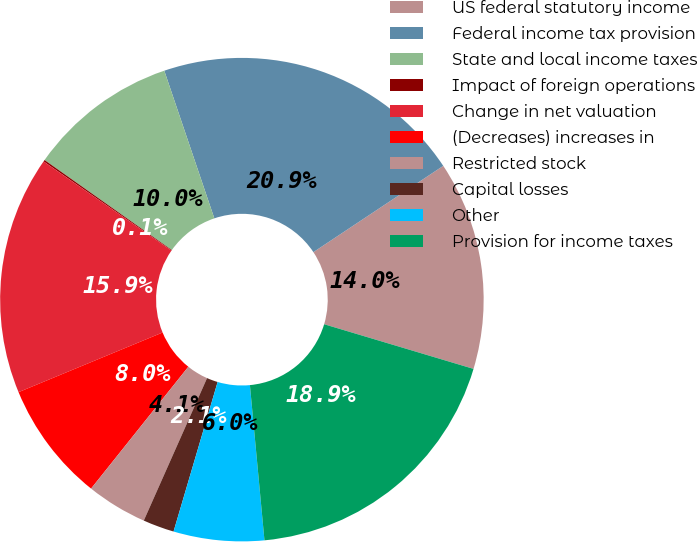Convert chart to OTSL. <chart><loc_0><loc_0><loc_500><loc_500><pie_chart><fcel>US federal statutory income<fcel>Federal income tax provision<fcel>State and local income taxes<fcel>Impact of foreign operations<fcel>Change in net valuation<fcel>(Decreases) increases in<fcel>Restricted stock<fcel>Capital losses<fcel>Other<fcel>Provision for income taxes<nl><fcel>13.96%<fcel>20.87%<fcel>10.0%<fcel>0.11%<fcel>15.94%<fcel>8.03%<fcel>4.07%<fcel>2.09%<fcel>6.05%<fcel>18.89%<nl></chart> 